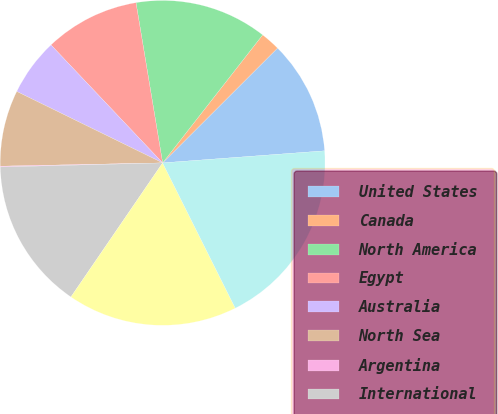<chart> <loc_0><loc_0><loc_500><loc_500><pie_chart><fcel>United States<fcel>Canada<fcel>North America<fcel>Egypt<fcel>Australia<fcel>North Sea<fcel>Argentina<fcel>International<fcel>Total (1)<fcel>Total (2)<nl><fcel>11.31%<fcel>1.95%<fcel>13.18%<fcel>9.44%<fcel>5.69%<fcel>7.57%<fcel>0.08%<fcel>15.05%<fcel>16.93%<fcel>18.8%<nl></chart> 